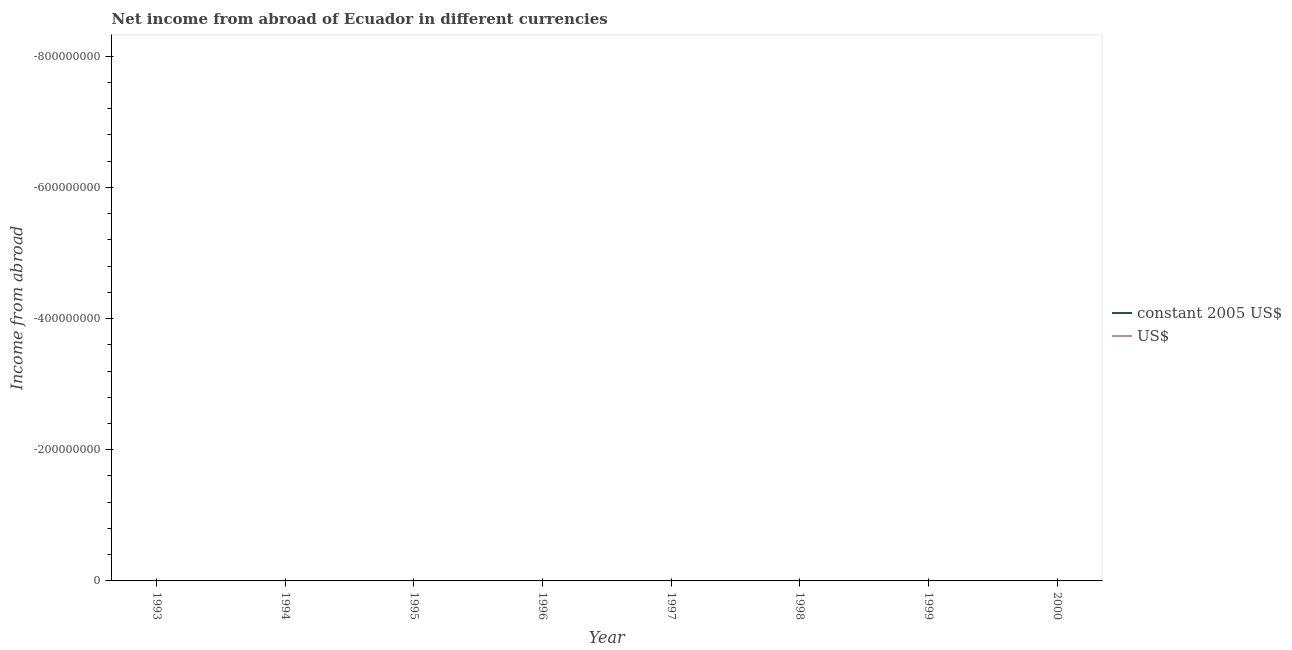How many different coloured lines are there?
Offer a very short reply. 0. Does the line corresponding to income from abroad in us$ intersect with the line corresponding to income from abroad in constant 2005 us$?
Your response must be concise. No. What is the income from abroad in constant 2005 us$ in 1996?
Offer a terse response. 0. What is the average income from abroad in constant 2005 us$ per year?
Your answer should be very brief. 0. In how many years, is the income from abroad in constant 2005 us$ greater than the average income from abroad in constant 2005 us$ taken over all years?
Ensure brevity in your answer.  0. Does the income from abroad in us$ monotonically increase over the years?
Offer a terse response. No. Is the income from abroad in us$ strictly greater than the income from abroad in constant 2005 us$ over the years?
Provide a short and direct response. No. Is the income from abroad in us$ strictly less than the income from abroad in constant 2005 us$ over the years?
Ensure brevity in your answer.  Yes. How many years are there in the graph?
Your answer should be compact. 8. What is the difference between two consecutive major ticks on the Y-axis?
Give a very brief answer. 2.00e+08. Are the values on the major ticks of Y-axis written in scientific E-notation?
Your response must be concise. No. Does the graph contain any zero values?
Provide a short and direct response. Yes. How many legend labels are there?
Offer a very short reply. 2. What is the title of the graph?
Your answer should be very brief. Net income from abroad of Ecuador in different currencies. What is the label or title of the X-axis?
Your response must be concise. Year. What is the label or title of the Y-axis?
Ensure brevity in your answer.  Income from abroad. What is the Income from abroad of US$ in 1993?
Your response must be concise. 0. What is the Income from abroad of constant 2005 US$ in 1994?
Give a very brief answer. 0. What is the Income from abroad in US$ in 1994?
Provide a succinct answer. 0. What is the Income from abroad of constant 2005 US$ in 1995?
Your answer should be very brief. 0. What is the Income from abroad in US$ in 1997?
Give a very brief answer. 0. What is the Income from abroad of constant 2005 US$ in 1998?
Provide a succinct answer. 0. What is the Income from abroad of constant 2005 US$ in 1999?
Provide a succinct answer. 0. What is the Income from abroad of US$ in 1999?
Offer a terse response. 0. What is the Income from abroad in US$ in 2000?
Your answer should be compact. 0. What is the total Income from abroad in constant 2005 US$ in the graph?
Make the answer very short. 0. What is the total Income from abroad in US$ in the graph?
Provide a succinct answer. 0. What is the average Income from abroad in constant 2005 US$ per year?
Offer a very short reply. 0. 